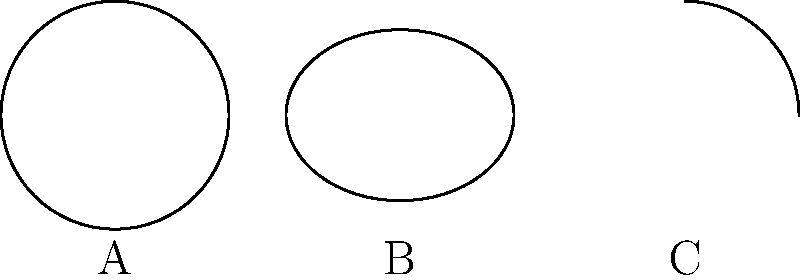In ancient astronomical manuscripts, three instruments are commonly depicted. Based on the simplified representations shown above, which instrument is most likely to be an astrolabe? To answer this question, we need to analyze the characteristics of each instrument depicted and compare them to what we know about astrolabes:

1. Instrument A: This is a perfect circle, which is consistent with the typical shape of an astrolabe. Astrolabes were usually circular discs with various markings and movable parts.

2. Instrument B: This is an ellipse, which is more characteristic of an armillary sphere. Armillary spheres were typically depicted as a series of rings representing celestial circles.

3. Instrument C: This is a quarter circle, which is representative of a quadrant. Quadrants were used for measuring angles in the sky and were often depicted as a quarter of a circle.

Astrolabes were flat, circular instruments used for various astronomical calculations and observations. They were one of the most important astronomical tools in both the Islamic world and medieval Europe. The circular shape of Instrument A most closely matches the typical representation of an astrolabe in historical manuscripts.

Therefore, Instrument A is most likely to be an astrolabe.
Answer: A 